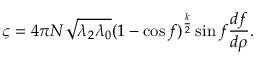<formula> <loc_0><loc_0><loc_500><loc_500>\varsigma = 4 \pi N \sqrt { \lambda _ { 2 } \lambda _ { 0 } } ( 1 - \cos f ) ^ { \frac { k } { 2 } } \sin f \frac { d f } { d \rho } .</formula> 